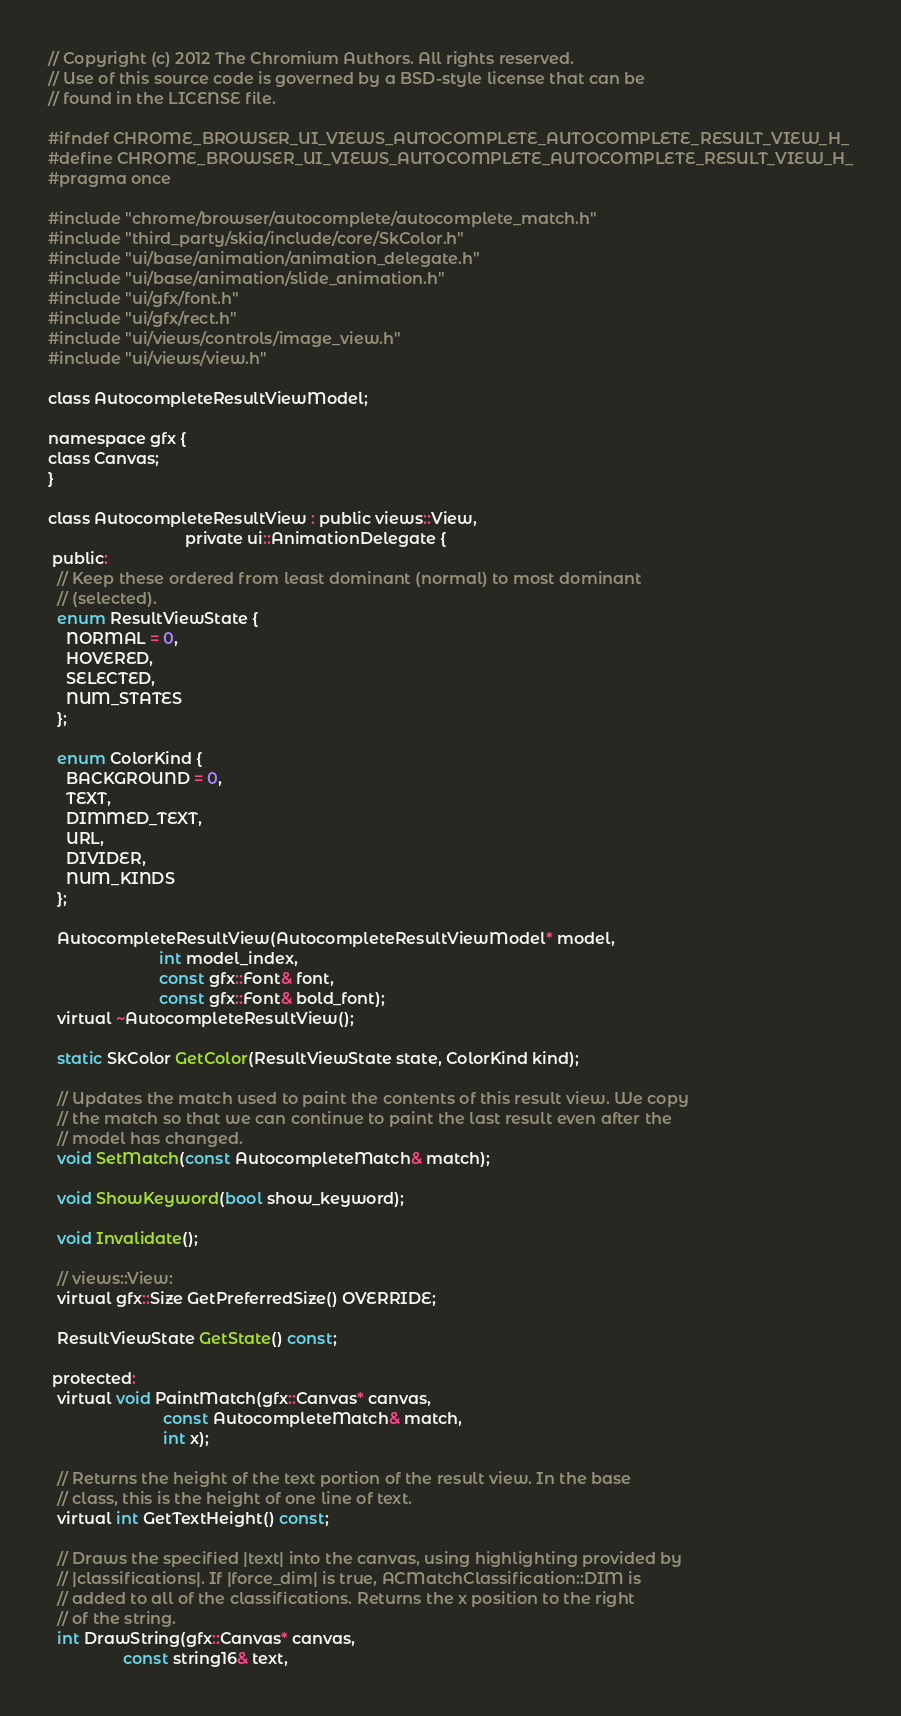Convert code to text. <code><loc_0><loc_0><loc_500><loc_500><_C_>// Copyright (c) 2012 The Chromium Authors. All rights reserved.
// Use of this source code is governed by a BSD-style license that can be
// found in the LICENSE file.

#ifndef CHROME_BROWSER_UI_VIEWS_AUTOCOMPLETE_AUTOCOMPLETE_RESULT_VIEW_H_
#define CHROME_BROWSER_UI_VIEWS_AUTOCOMPLETE_AUTOCOMPLETE_RESULT_VIEW_H_
#pragma once

#include "chrome/browser/autocomplete/autocomplete_match.h"
#include "third_party/skia/include/core/SkColor.h"
#include "ui/base/animation/animation_delegate.h"
#include "ui/base/animation/slide_animation.h"
#include "ui/gfx/font.h"
#include "ui/gfx/rect.h"
#include "ui/views/controls/image_view.h"
#include "ui/views/view.h"

class AutocompleteResultViewModel;

namespace gfx {
class Canvas;
}

class AutocompleteResultView : public views::View,
                               private ui::AnimationDelegate {
 public:
  // Keep these ordered from least dominant (normal) to most dominant
  // (selected).
  enum ResultViewState {
    NORMAL = 0,
    HOVERED,
    SELECTED,
    NUM_STATES
  };

  enum ColorKind {
    BACKGROUND = 0,
    TEXT,
    DIMMED_TEXT,
    URL,
    DIVIDER,
    NUM_KINDS
  };

  AutocompleteResultView(AutocompleteResultViewModel* model,
                         int model_index,
                         const gfx::Font& font,
                         const gfx::Font& bold_font);
  virtual ~AutocompleteResultView();

  static SkColor GetColor(ResultViewState state, ColorKind kind);

  // Updates the match used to paint the contents of this result view. We copy
  // the match so that we can continue to paint the last result even after the
  // model has changed.
  void SetMatch(const AutocompleteMatch& match);

  void ShowKeyword(bool show_keyword);

  void Invalidate();

  // views::View:
  virtual gfx::Size GetPreferredSize() OVERRIDE;

  ResultViewState GetState() const;

 protected:
  virtual void PaintMatch(gfx::Canvas* canvas,
                          const AutocompleteMatch& match,
                          int x);

  // Returns the height of the text portion of the result view. In the base
  // class, this is the height of one line of text.
  virtual int GetTextHeight() const;

  // Draws the specified |text| into the canvas, using highlighting provided by
  // |classifications|. If |force_dim| is true, ACMatchClassification::DIM is
  // added to all of the classifications. Returns the x position to the right
  // of the string.
  int DrawString(gfx::Canvas* canvas,
                 const string16& text,</code> 